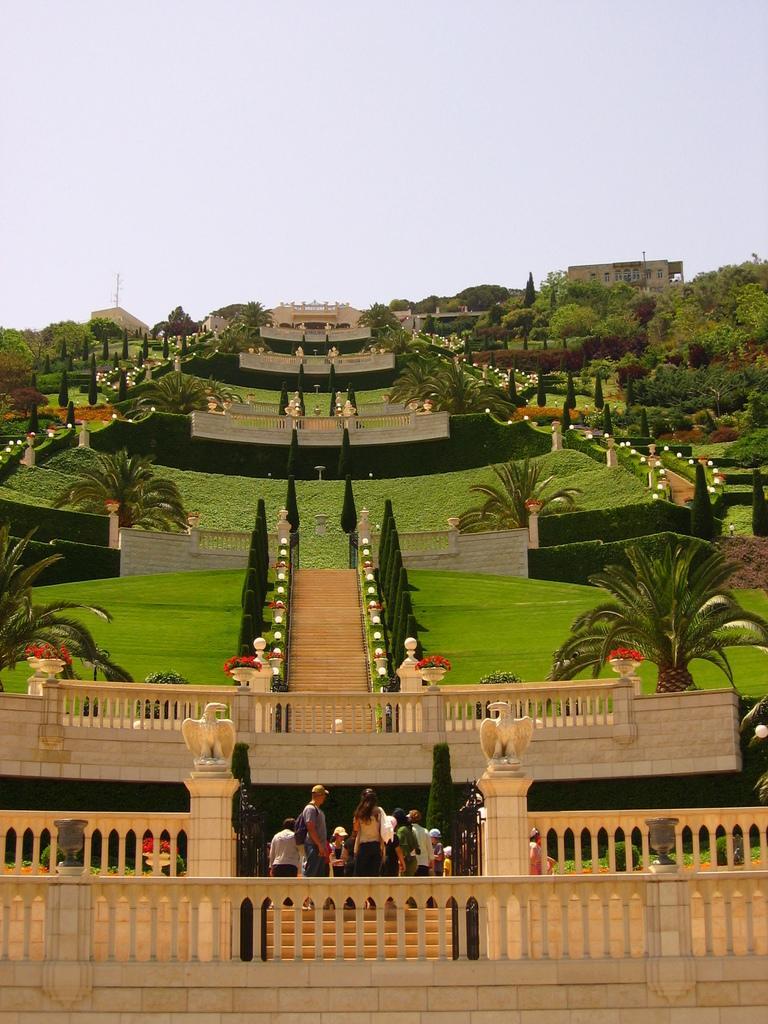Describe this image in one or two sentences. In this picture I can see few people standing near staircases, behind there are some staircases, walls, trees and grass. 